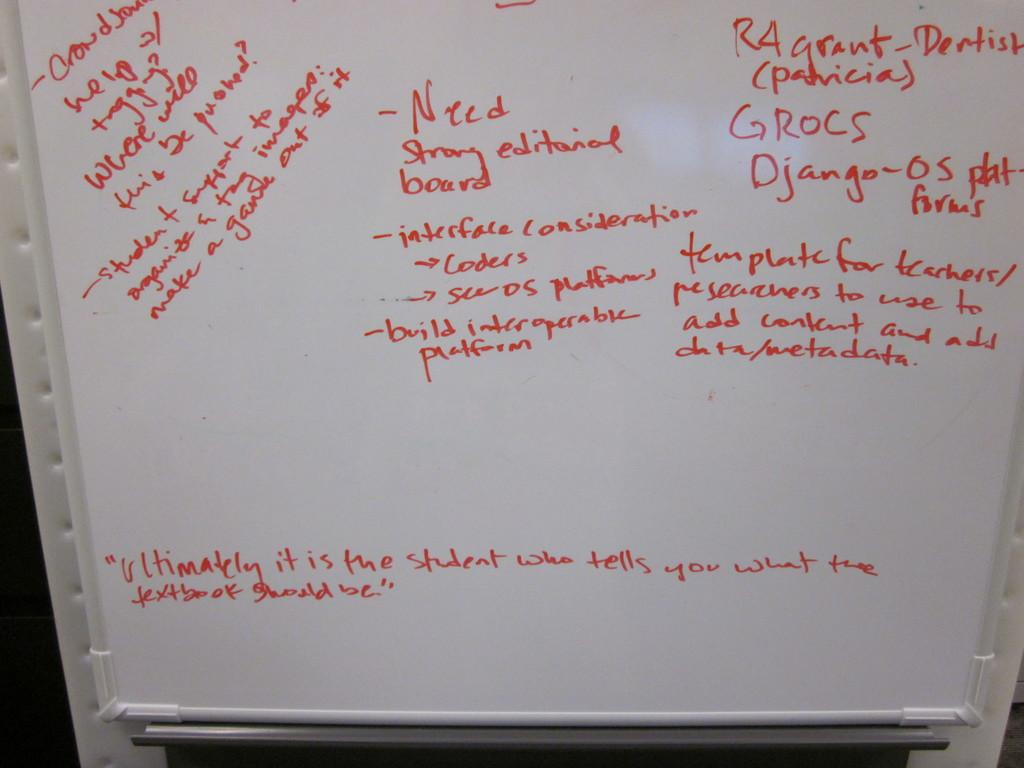Provide a one-sentence caption for the provided image. A white board with red writing indicates that someone needs a "strong editorial board.". 